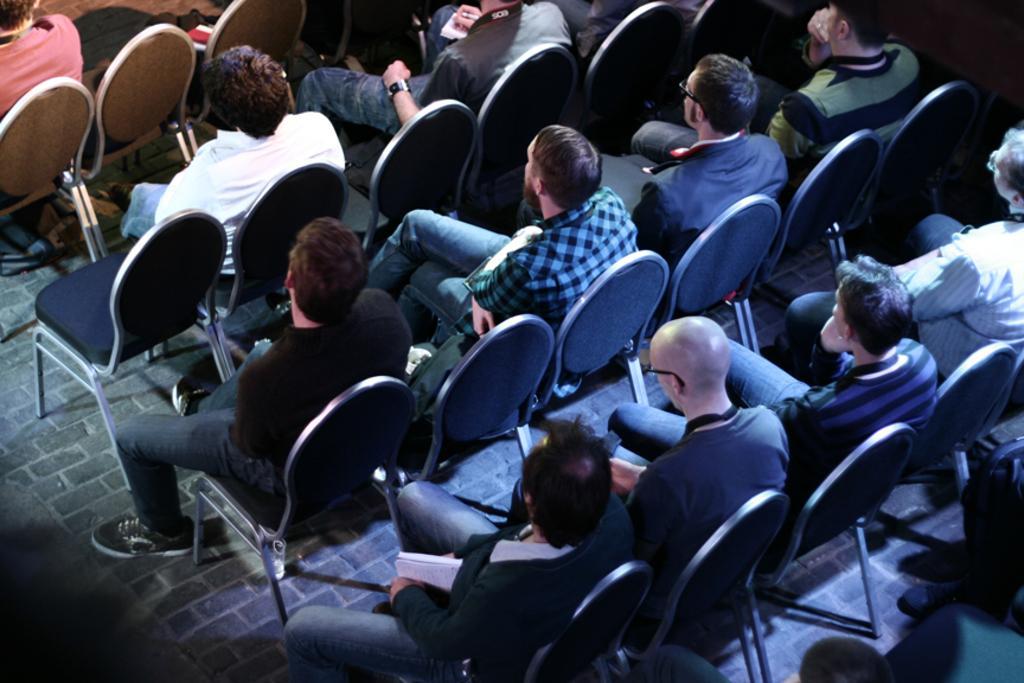Could you give a brief overview of what you see in this image? I think this picture is taken in a room, the room is filled with the chairs and people. All the people are staring backwards. 